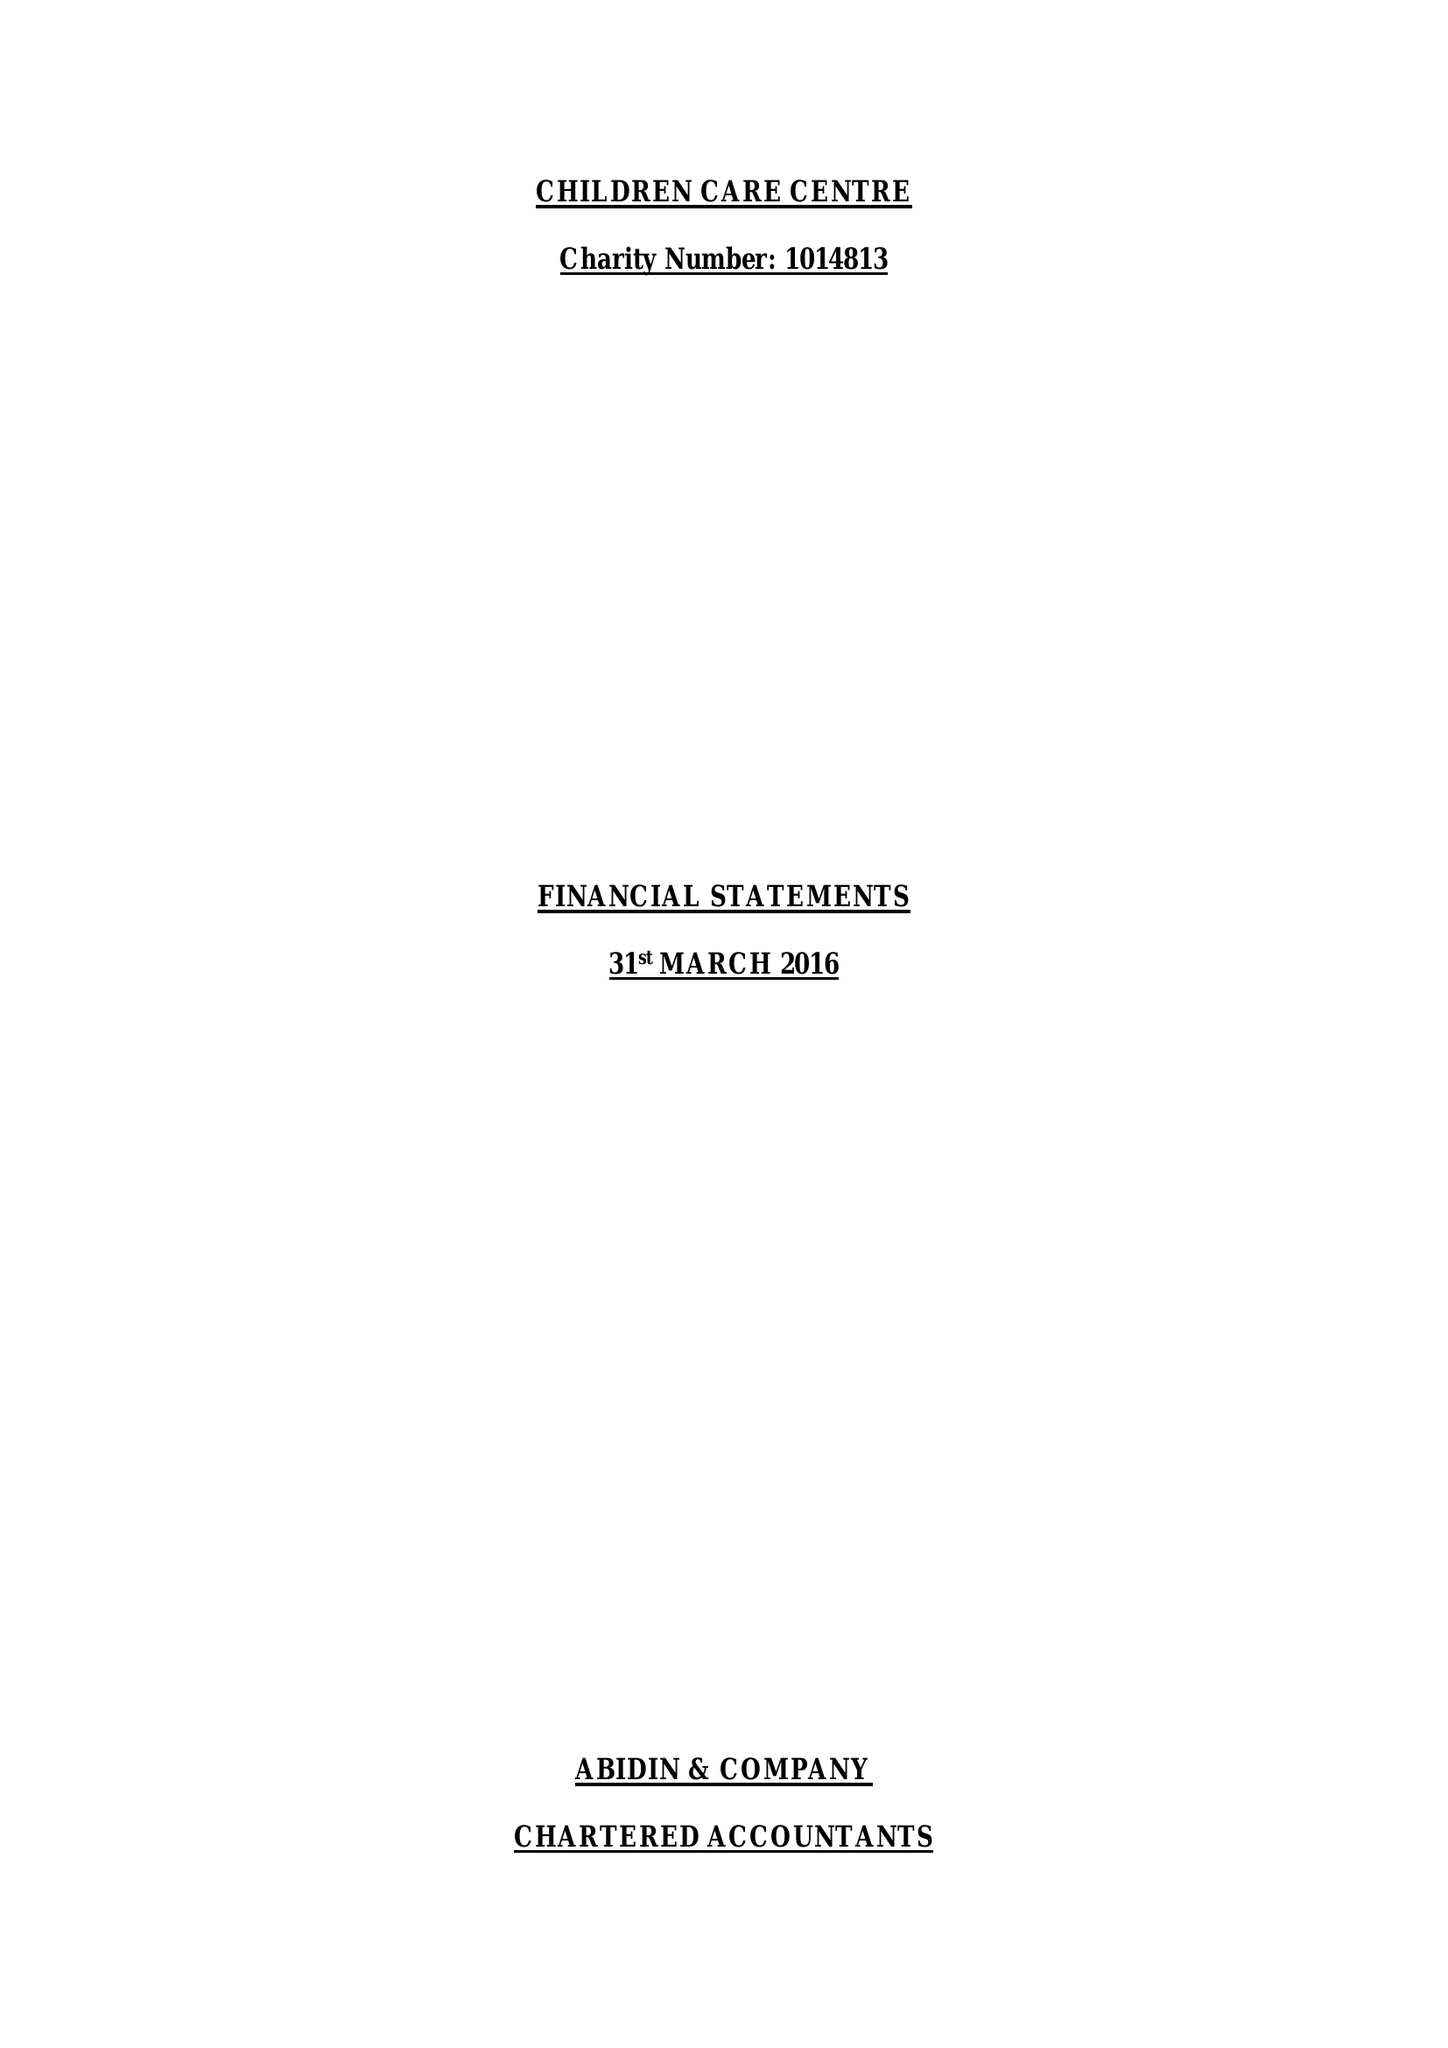What is the value for the spending_annually_in_british_pounds?
Answer the question using a single word or phrase. 97243.00 